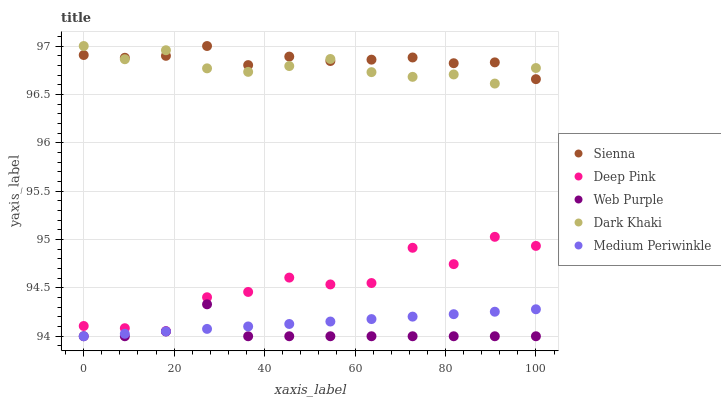Does Web Purple have the minimum area under the curve?
Answer yes or no. Yes. Does Sienna have the maximum area under the curve?
Answer yes or no. Yes. Does Dark Khaki have the minimum area under the curve?
Answer yes or no. No. Does Dark Khaki have the maximum area under the curve?
Answer yes or no. No. Is Medium Periwinkle the smoothest?
Answer yes or no. Yes. Is Deep Pink the roughest?
Answer yes or no. Yes. Is Dark Khaki the smoothest?
Answer yes or no. No. Is Dark Khaki the roughest?
Answer yes or no. No. Does Web Purple have the lowest value?
Answer yes or no. Yes. Does Dark Khaki have the lowest value?
Answer yes or no. No. Does Dark Khaki have the highest value?
Answer yes or no. Yes. Does Web Purple have the highest value?
Answer yes or no. No. Is Deep Pink less than Sienna?
Answer yes or no. Yes. Is Dark Khaki greater than Medium Periwinkle?
Answer yes or no. Yes. Does Medium Periwinkle intersect Web Purple?
Answer yes or no. Yes. Is Medium Periwinkle less than Web Purple?
Answer yes or no. No. Is Medium Periwinkle greater than Web Purple?
Answer yes or no. No. Does Deep Pink intersect Sienna?
Answer yes or no. No. 